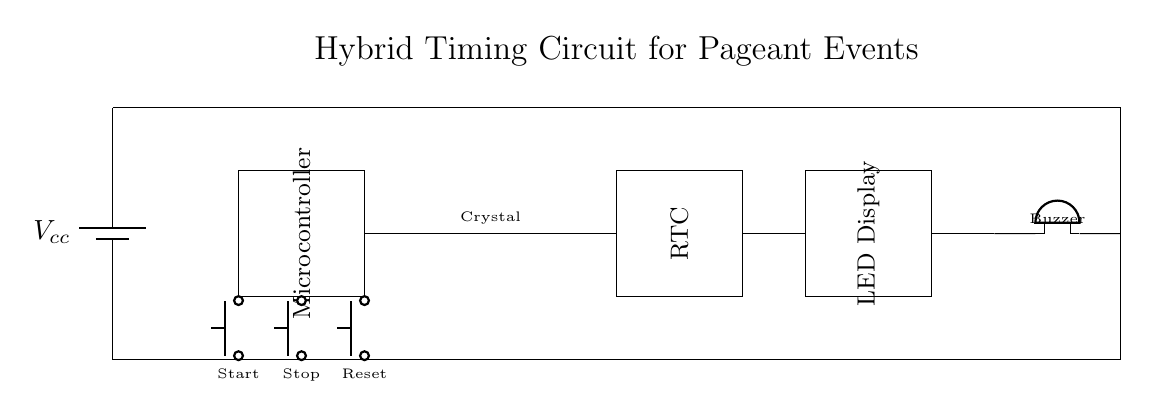What type of microcontroller is used in this circuit? The diagram shows a rectangle labeled "Microcontroller," indicating that a microcontroller is present, but does not provide specific details on the model. Therefore, the answer focuses on the type rather than a specific model or brand.
Answer: Microcontroller What component generates timing signals? The crystal oscillator is labeled in the diagram and is identified as the component responsible for generating specific timing signals due to its nature of producing consistent oscillations.
Answer: Crystal oscillator How many input buttons are there? The diagram visually represents three buttons labeled "Start," "Stop," and "Reset," confirming the total count of input buttons present in the circuit.
Answer: Three What function does the buzzer serve? The diagram labels the buzzer as a signaling device typically used for alerts or cues, indicating that its function is to produce sound signals during the event scheduling process.
Answer: Alert How does the microcontroller interact with the RTC? The microcontroller is connected to the Real-Time Clock (RTC) component through associated lines in the diagram, suggesting a data exchange between them to keep track of time and manage events.
Answer: Data exchange What is the purpose of the LED display? The LED display is marked in the diagram, indicating that it is used to visually show the current timing or cues based on the information from the microcontroller, likely providing feedback during the event.
Answer: Visual feedback 